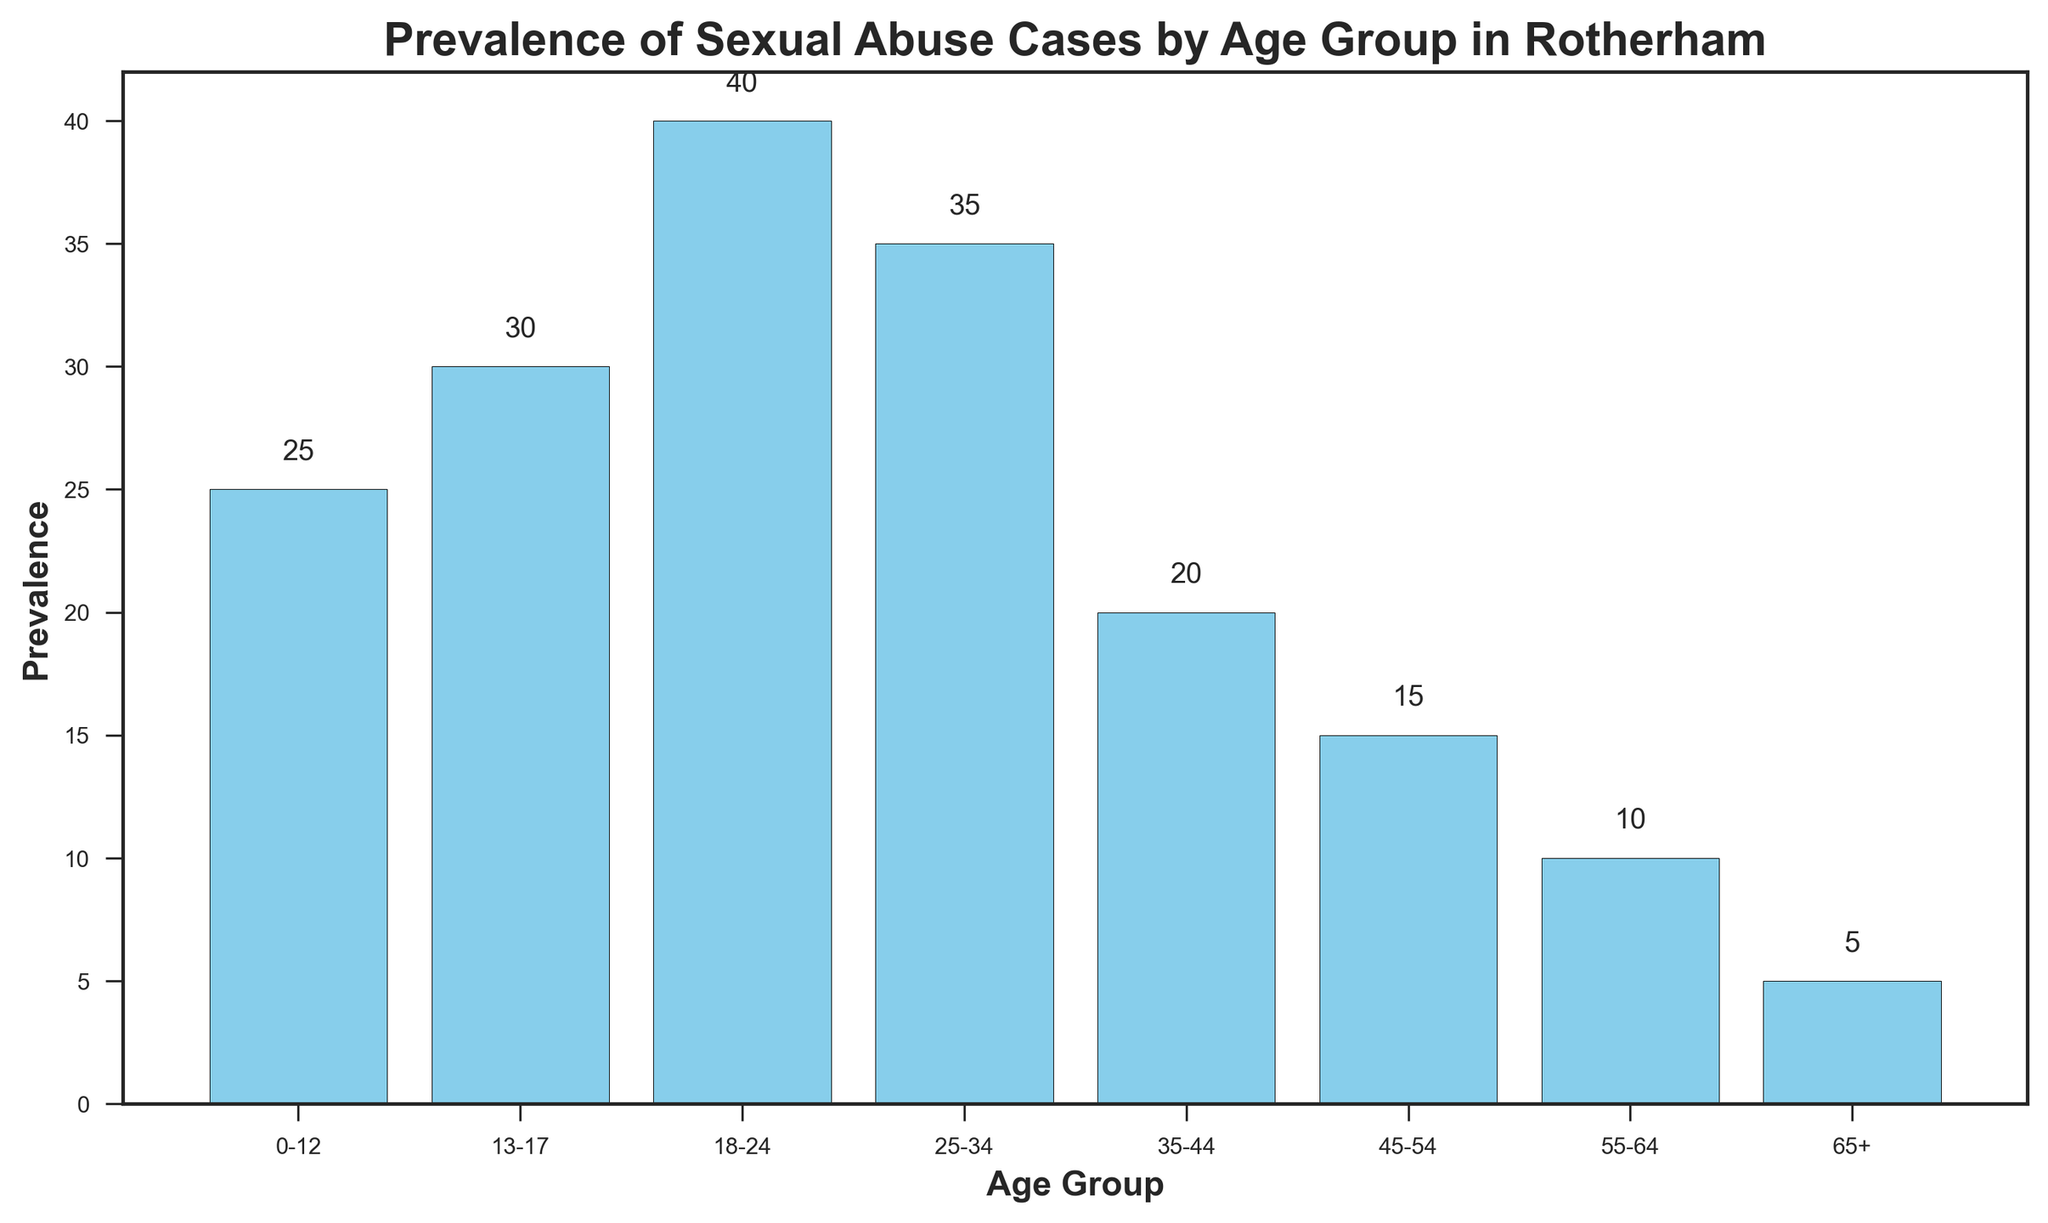What age group has the highest prevalence of sexual abuse cases? The age group with the highest prevalence of sexual abuse cases can be identified by looking at the tallest bar in the bar chart. The bar corresponding to the age group 18-24 is the tallest.
Answer: 18-24 What is the total number of sexual abuse cases across all age groups? To find the total number of sexual abuse cases across all age groups, sum the prevalence values of each age group: 25 + 30 + 40 + 35 + 20 + 15 + 10 + 5 = 180.
Answer: 180 Which age group has a higher prevalence of sexual abuse cases, 13-17 or 25-34? By comparing the heights of the bars corresponding to age groups 13-17 and 25-34, it is clear that the bar for 25-34 (prevalence 35) is taller than the bar for 13-17 (prevalence 30).
Answer: 25-34 What is the difference in prevalence of sexual abuse cases between the age groups 0-12 and 65+? The prevalence of the 0-12 age group is 25, and the prevalence of the 65+ age group is 5. The difference is calculated by subtracting the smaller value from the larger value: 25 - 5 = 20.
Answer: 20 What is the average prevalence of sexual abuse cases for all age groups? To find the average prevalence, sum the prevalence values for all age groups and divide by the number of age groups: (25 + 30 + 40 + 35 + 20 + 15 + 10 + 5) / 8 = 180 / 8 = 22.5.
Answer: 22.5 Which age group has the lowest prevalence of sexual abuse cases? The age group with the lowest prevalence of sexual abuse cases is identified by finding the shortest bar in the bar chart. The bar corresponding to the age group 65+ is the shortest.
Answer: 65+ How much higher is the prevalence of sexual abuse cases in age group 18-24 compared to 55-64? The prevalence for the age group 18-24 is 40, and for 55-64 it is 10. The difference is calculated by subtracting the smaller value from the larger value: 40 - 10 = 30.
Answer: 30 What is the combined prevalence of sexual abuse cases for the age groups 0-12, 13-17, and 18-24? To find the combined prevalence, sum the prevalence values for these age groups: 25 + 30 + 40 = 95.
Answer: 95 What is the visual pattern of prevalence as age increases? Observing the bar chart, as age increases, the prevalence of sexual abuse cases initially increases, peaking at the 18-24 age group, then decreases steadily for older age groups.
Answer: Increases then decreases 